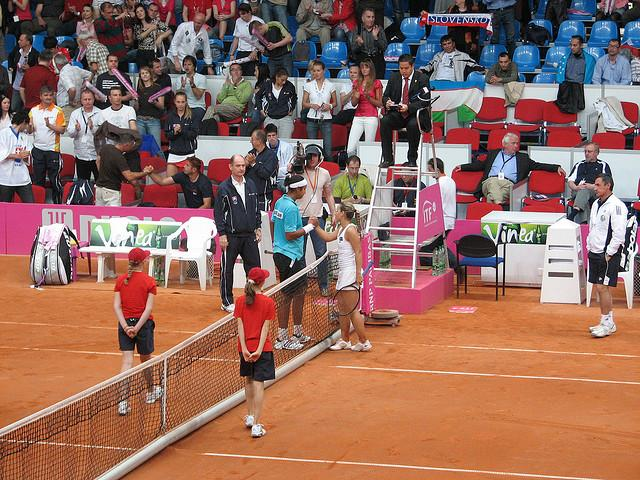At which point in the match are these players? end 